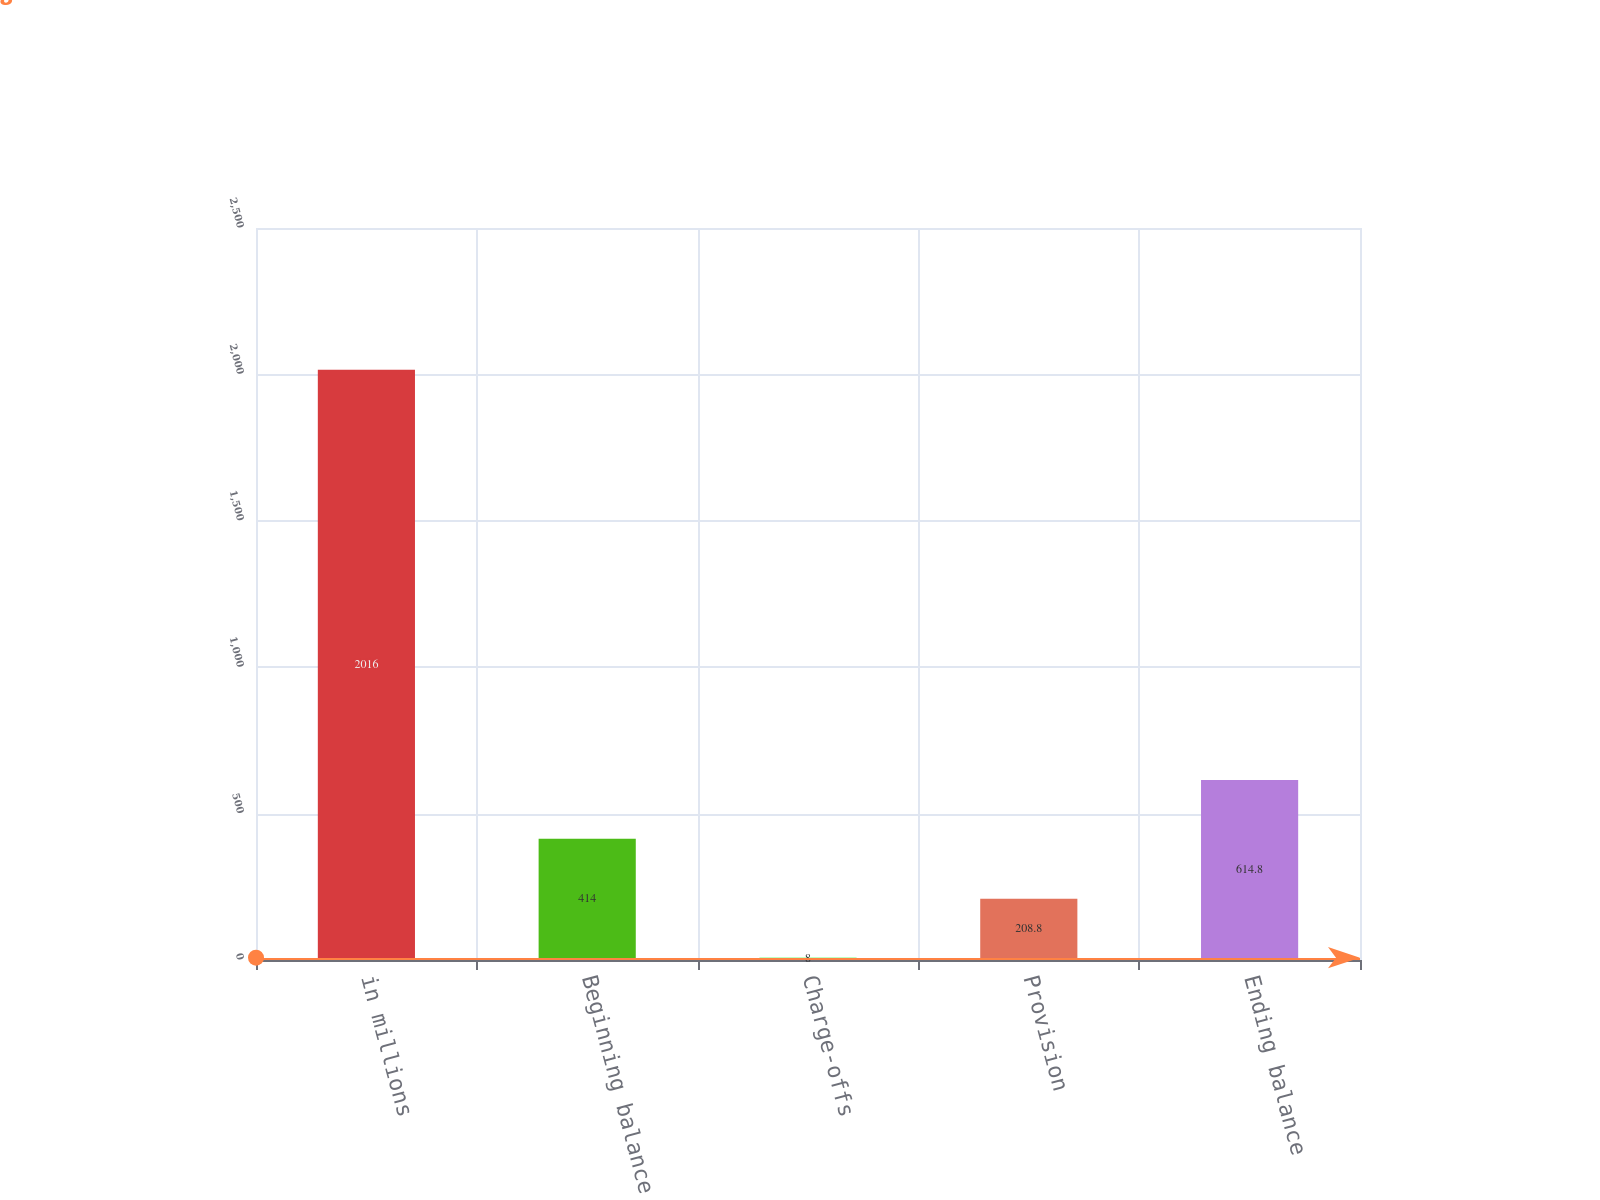<chart> <loc_0><loc_0><loc_500><loc_500><bar_chart><fcel>in millions<fcel>Beginning balance<fcel>Charge-offs<fcel>Provision<fcel>Ending balance<nl><fcel>2016<fcel>414<fcel>8<fcel>208.8<fcel>614.8<nl></chart> 